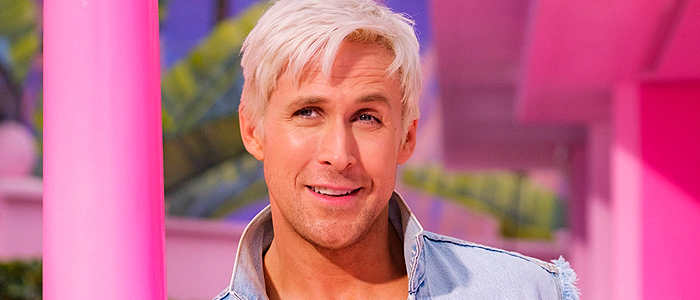What might be the setting or event for this photograph? This image could be taken at a vibrant urban event or a fashion-oriented setting, given the vivid colors and casual yet stylish ensemble of the subject. The backdrop and attire suggest a youthful, trendy environment, possibly a gallery opening or a casual city event. How does the color scheme of the background influence the mood of the image? The pink and yellow hues in the background create a playful and energetic atmosphere. These colors tend to evoke feelings of happiness and vivacity, which are complemented by the subject’s relaxed pose and smile, overall enhancing the inviting and warm mood of the image. 